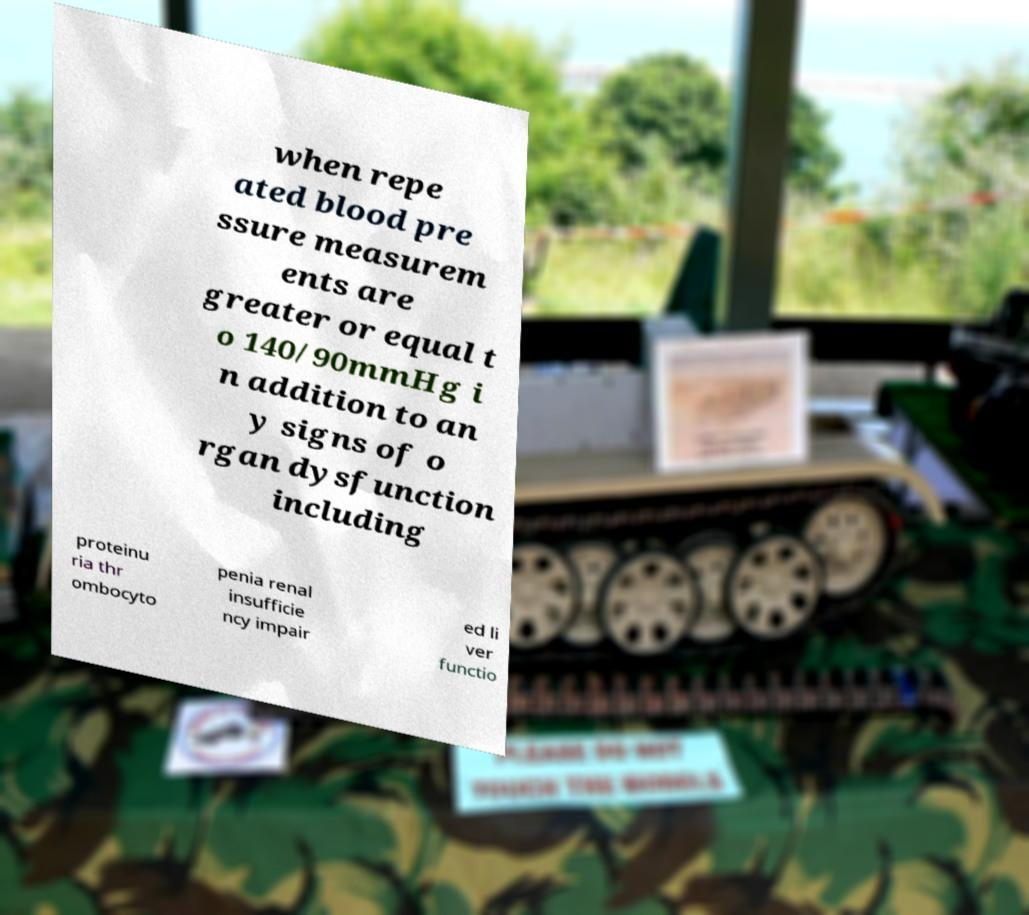Please identify and transcribe the text found in this image. when repe ated blood pre ssure measurem ents are greater or equal t o 140/90mmHg i n addition to an y signs of o rgan dysfunction including proteinu ria thr ombocyto penia renal insufficie ncy impair ed li ver functio 